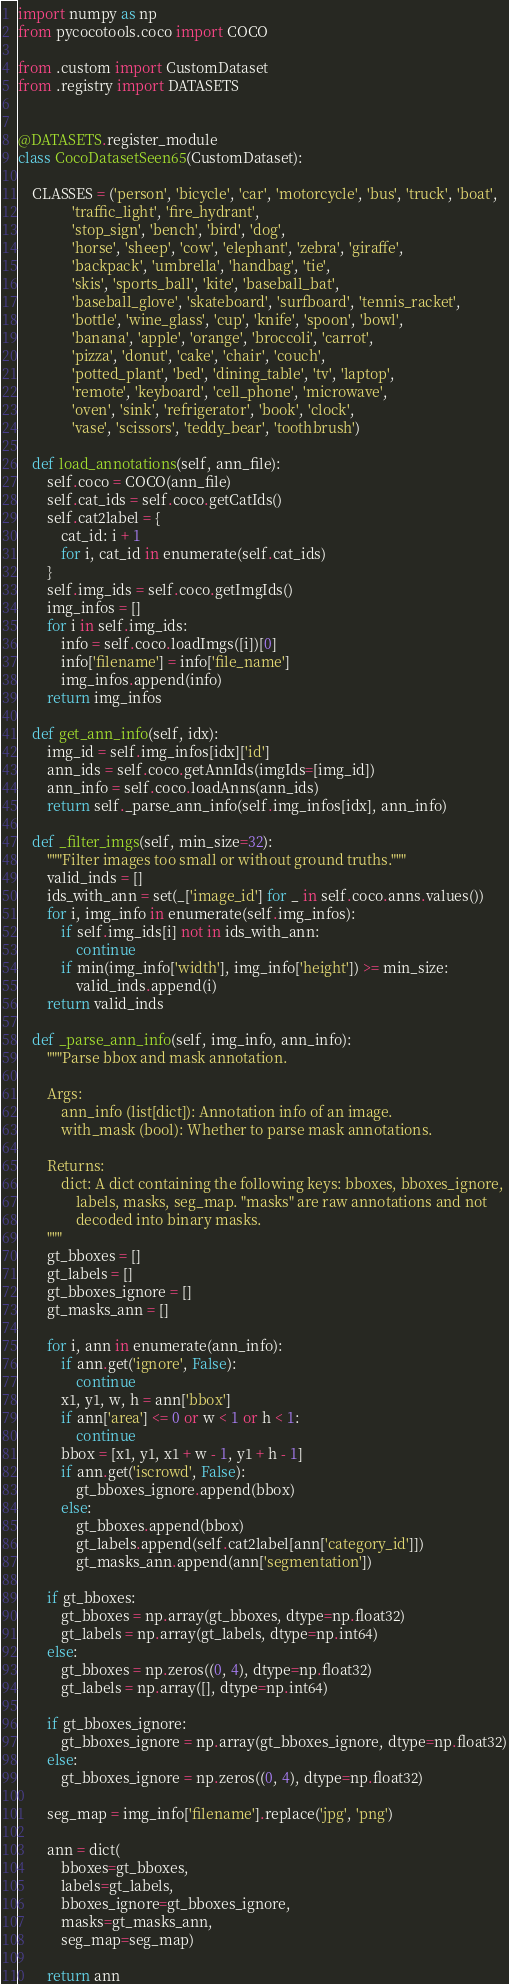<code> <loc_0><loc_0><loc_500><loc_500><_Python_>import numpy as np
from pycocotools.coco import COCO

from .custom import CustomDataset
from .registry import DATASETS


@DATASETS.register_module
class CocoDatasetSeen65(CustomDataset):

    CLASSES = ('person', 'bicycle', 'car', 'motorcycle', 'bus', 'truck', 'boat',
               'traffic_light', 'fire_hydrant',
               'stop_sign', 'bench', 'bird', 'dog',
               'horse', 'sheep', 'cow', 'elephant', 'zebra', 'giraffe',
               'backpack', 'umbrella', 'handbag', 'tie',
               'skis', 'sports_ball', 'kite', 'baseball_bat',
               'baseball_glove', 'skateboard', 'surfboard', 'tennis_racket',
               'bottle', 'wine_glass', 'cup', 'knife', 'spoon', 'bowl',
               'banana', 'apple', 'orange', 'broccoli', 'carrot',
               'pizza', 'donut', 'cake', 'chair', 'couch',
               'potted_plant', 'bed', 'dining_table', 'tv', 'laptop',
               'remote', 'keyboard', 'cell_phone', 'microwave',
               'oven', 'sink', 'refrigerator', 'book', 'clock',
               'vase', 'scissors', 'teddy_bear', 'toothbrush')

    def load_annotations(self, ann_file):
        self.coco = COCO(ann_file)
        self.cat_ids = self.coco.getCatIds()
        self.cat2label = {
            cat_id: i + 1
            for i, cat_id in enumerate(self.cat_ids)
        }
        self.img_ids = self.coco.getImgIds()
        img_infos = []
        for i in self.img_ids:
            info = self.coco.loadImgs([i])[0]
            info['filename'] = info['file_name']
            img_infos.append(info)
        return img_infos

    def get_ann_info(self, idx):
        img_id = self.img_infos[idx]['id']
        ann_ids = self.coco.getAnnIds(imgIds=[img_id])
        ann_info = self.coco.loadAnns(ann_ids)
        return self._parse_ann_info(self.img_infos[idx], ann_info)

    def _filter_imgs(self, min_size=32):
        """Filter images too small or without ground truths."""
        valid_inds = []
        ids_with_ann = set(_['image_id'] for _ in self.coco.anns.values())
        for i, img_info in enumerate(self.img_infos):
            if self.img_ids[i] not in ids_with_ann:
                continue
            if min(img_info['width'], img_info['height']) >= min_size:
                valid_inds.append(i)
        return valid_inds

    def _parse_ann_info(self, img_info, ann_info):
        """Parse bbox and mask annotation.

        Args:
            ann_info (list[dict]): Annotation info of an image.
            with_mask (bool): Whether to parse mask annotations.

        Returns:
            dict: A dict containing the following keys: bboxes, bboxes_ignore,
                labels, masks, seg_map. "masks" are raw annotations and not
                decoded into binary masks.
        """
        gt_bboxes = []
        gt_labels = []
        gt_bboxes_ignore = []
        gt_masks_ann = []

        for i, ann in enumerate(ann_info):
            if ann.get('ignore', False):
                continue
            x1, y1, w, h = ann['bbox']
            if ann['area'] <= 0 or w < 1 or h < 1:
                continue
            bbox = [x1, y1, x1 + w - 1, y1 + h - 1]
            if ann.get('iscrowd', False):
                gt_bboxes_ignore.append(bbox)
            else:
                gt_bboxes.append(bbox)
                gt_labels.append(self.cat2label[ann['category_id']])
                gt_masks_ann.append(ann['segmentation'])

        if gt_bboxes:
            gt_bboxes = np.array(gt_bboxes, dtype=np.float32)
            gt_labels = np.array(gt_labels, dtype=np.int64)
        else:
            gt_bboxes = np.zeros((0, 4), dtype=np.float32)
            gt_labels = np.array([], dtype=np.int64)

        if gt_bboxes_ignore:
            gt_bboxes_ignore = np.array(gt_bboxes_ignore, dtype=np.float32)
        else:
            gt_bboxes_ignore = np.zeros((0, 4), dtype=np.float32)

        seg_map = img_info['filename'].replace('jpg', 'png')

        ann = dict(
            bboxes=gt_bboxes,
            labels=gt_labels,
            bboxes_ignore=gt_bboxes_ignore,
            masks=gt_masks_ann,
            seg_map=seg_map)

        return ann
</code> 